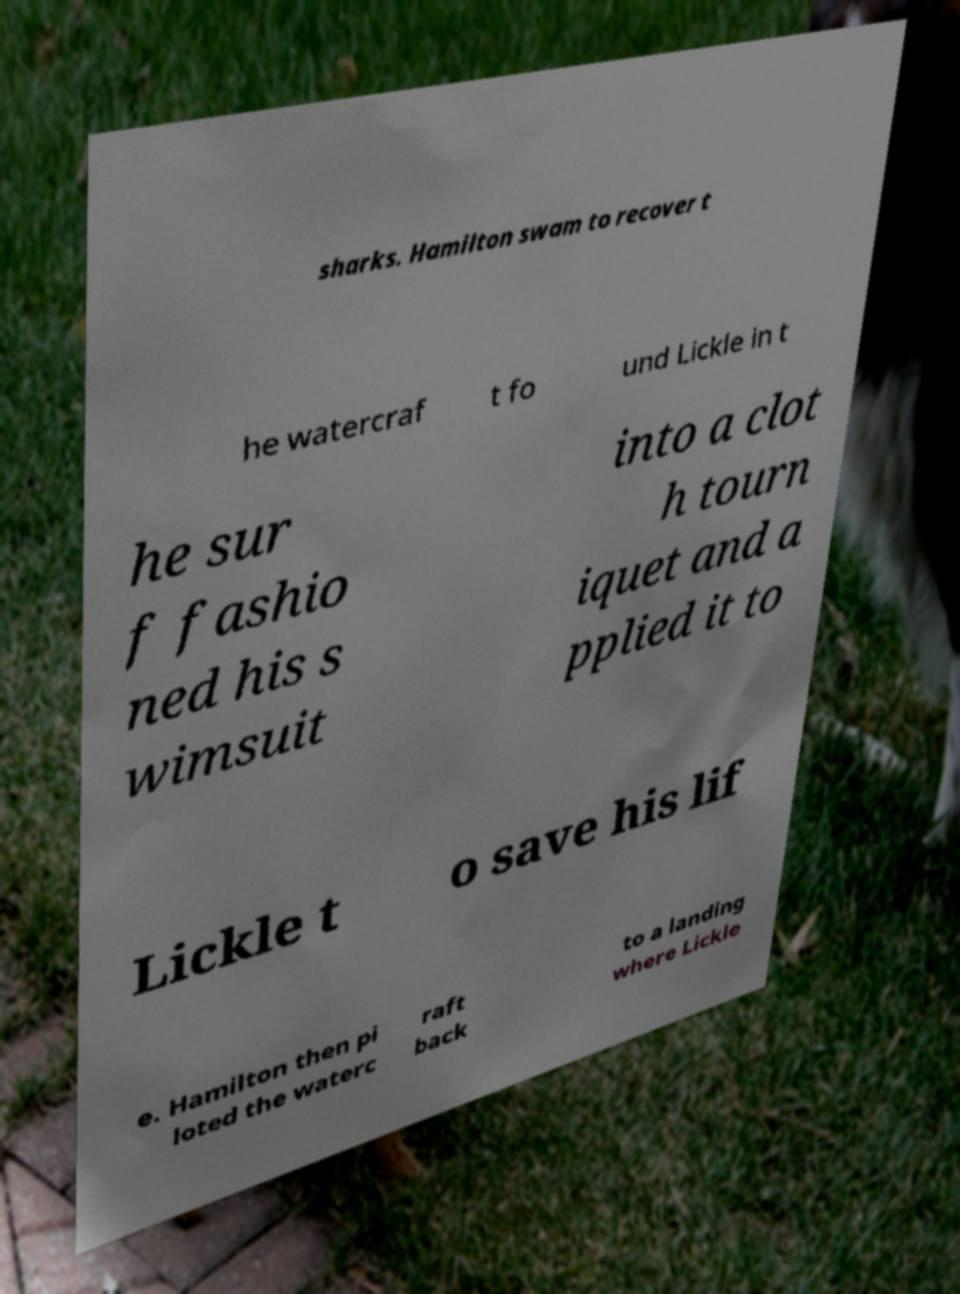What messages or text are displayed in this image? I need them in a readable, typed format. sharks. Hamilton swam to recover t he watercraf t fo und Lickle in t he sur f fashio ned his s wimsuit into a clot h tourn iquet and a pplied it to Lickle t o save his lif e. Hamilton then pi loted the waterc raft back to a landing where Lickle 